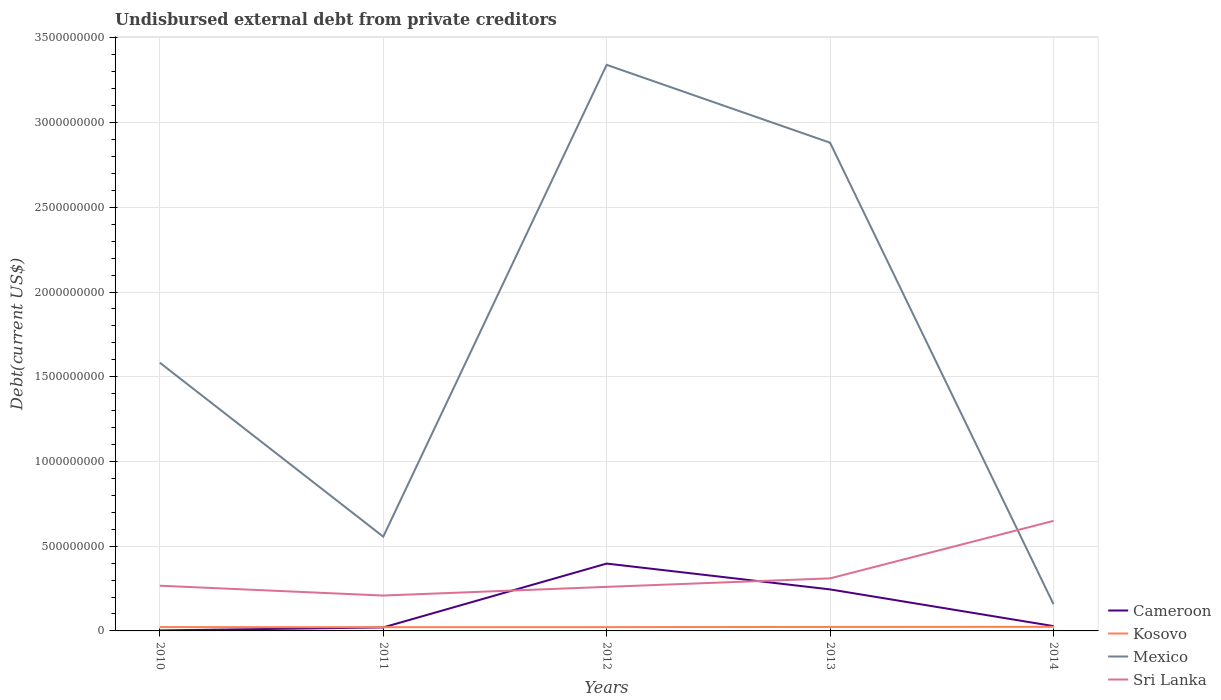Is the number of lines equal to the number of legend labels?
Ensure brevity in your answer.  Yes. Across all years, what is the maximum total debt in Sri Lanka?
Ensure brevity in your answer.  2.09e+08. In which year was the total debt in Kosovo maximum?
Your answer should be compact. 2011. What is the total total debt in Sri Lanka in the graph?
Ensure brevity in your answer.  -5.13e+07. What is the difference between the highest and the second highest total debt in Sri Lanka?
Your answer should be compact. 4.41e+08. How many lines are there?
Your answer should be very brief. 4. How many years are there in the graph?
Offer a very short reply. 5. What is the difference between two consecutive major ticks on the Y-axis?
Give a very brief answer. 5.00e+08. Are the values on the major ticks of Y-axis written in scientific E-notation?
Keep it short and to the point. No. Does the graph contain grids?
Your response must be concise. Yes. Where does the legend appear in the graph?
Provide a short and direct response. Bottom right. How are the legend labels stacked?
Give a very brief answer. Vertical. What is the title of the graph?
Provide a succinct answer. Undisbursed external debt from private creditors. What is the label or title of the X-axis?
Give a very brief answer. Years. What is the label or title of the Y-axis?
Offer a very short reply. Debt(current US$). What is the Debt(current US$) of Cameroon in 2010?
Make the answer very short. 2.98e+06. What is the Debt(current US$) of Kosovo in 2010?
Your answer should be compact. 2.27e+07. What is the Debt(current US$) of Mexico in 2010?
Your answer should be compact. 1.58e+09. What is the Debt(current US$) of Sri Lanka in 2010?
Offer a terse response. 2.67e+08. What is the Debt(current US$) of Cameroon in 2011?
Ensure brevity in your answer.  2.07e+07. What is the Debt(current US$) of Kosovo in 2011?
Your answer should be very brief. 2.20e+07. What is the Debt(current US$) in Mexico in 2011?
Your answer should be very brief. 5.56e+08. What is the Debt(current US$) of Sri Lanka in 2011?
Provide a short and direct response. 2.09e+08. What is the Debt(current US$) of Cameroon in 2012?
Provide a short and direct response. 3.98e+08. What is the Debt(current US$) in Kosovo in 2012?
Provide a short and direct response. 2.24e+07. What is the Debt(current US$) in Mexico in 2012?
Keep it short and to the point. 3.34e+09. What is the Debt(current US$) in Sri Lanka in 2012?
Your response must be concise. 2.60e+08. What is the Debt(current US$) of Cameroon in 2013?
Your response must be concise. 2.45e+08. What is the Debt(current US$) in Kosovo in 2013?
Offer a very short reply. 2.34e+07. What is the Debt(current US$) in Mexico in 2013?
Give a very brief answer. 2.88e+09. What is the Debt(current US$) in Sri Lanka in 2013?
Provide a succinct answer. 3.10e+08. What is the Debt(current US$) of Cameroon in 2014?
Your answer should be very brief. 2.85e+07. What is the Debt(current US$) of Kosovo in 2014?
Ensure brevity in your answer.  2.42e+07. What is the Debt(current US$) of Mexico in 2014?
Your answer should be compact. 1.58e+08. What is the Debt(current US$) of Sri Lanka in 2014?
Provide a succinct answer. 6.49e+08. Across all years, what is the maximum Debt(current US$) of Cameroon?
Make the answer very short. 3.98e+08. Across all years, what is the maximum Debt(current US$) in Kosovo?
Keep it short and to the point. 2.42e+07. Across all years, what is the maximum Debt(current US$) of Mexico?
Provide a short and direct response. 3.34e+09. Across all years, what is the maximum Debt(current US$) in Sri Lanka?
Offer a terse response. 6.49e+08. Across all years, what is the minimum Debt(current US$) in Cameroon?
Offer a very short reply. 2.98e+06. Across all years, what is the minimum Debt(current US$) in Kosovo?
Your answer should be very brief. 2.20e+07. Across all years, what is the minimum Debt(current US$) in Mexico?
Ensure brevity in your answer.  1.58e+08. Across all years, what is the minimum Debt(current US$) of Sri Lanka?
Provide a succinct answer. 2.09e+08. What is the total Debt(current US$) of Cameroon in the graph?
Provide a succinct answer. 6.95e+08. What is the total Debt(current US$) of Kosovo in the graph?
Offer a terse response. 1.15e+08. What is the total Debt(current US$) of Mexico in the graph?
Make the answer very short. 8.52e+09. What is the total Debt(current US$) in Sri Lanka in the graph?
Make the answer very short. 1.70e+09. What is the difference between the Debt(current US$) in Cameroon in 2010 and that in 2011?
Offer a terse response. -1.77e+07. What is the difference between the Debt(current US$) of Kosovo in 2010 and that in 2011?
Offer a terse response. 7.19e+05. What is the difference between the Debt(current US$) in Mexico in 2010 and that in 2011?
Your answer should be very brief. 1.03e+09. What is the difference between the Debt(current US$) of Sri Lanka in 2010 and that in 2011?
Keep it short and to the point. 5.81e+07. What is the difference between the Debt(current US$) of Cameroon in 2010 and that in 2012?
Offer a very short reply. -3.95e+08. What is the difference between the Debt(current US$) in Kosovo in 2010 and that in 2012?
Your answer should be very brief. 2.85e+05. What is the difference between the Debt(current US$) of Mexico in 2010 and that in 2012?
Provide a short and direct response. -1.76e+09. What is the difference between the Debt(current US$) in Sri Lanka in 2010 and that in 2012?
Your answer should be very brief. 6.78e+06. What is the difference between the Debt(current US$) in Cameroon in 2010 and that in 2013?
Your response must be concise. -2.42e+08. What is the difference between the Debt(current US$) in Kosovo in 2010 and that in 2013?
Your answer should be compact. -7.30e+05. What is the difference between the Debt(current US$) of Mexico in 2010 and that in 2013?
Provide a succinct answer. -1.30e+09. What is the difference between the Debt(current US$) in Sri Lanka in 2010 and that in 2013?
Provide a short and direct response. -4.33e+07. What is the difference between the Debt(current US$) of Cameroon in 2010 and that in 2014?
Provide a short and direct response. -2.55e+07. What is the difference between the Debt(current US$) in Kosovo in 2010 and that in 2014?
Provide a succinct answer. -1.48e+06. What is the difference between the Debt(current US$) of Mexico in 2010 and that in 2014?
Make the answer very short. 1.42e+09. What is the difference between the Debt(current US$) of Sri Lanka in 2010 and that in 2014?
Ensure brevity in your answer.  -3.83e+08. What is the difference between the Debt(current US$) of Cameroon in 2011 and that in 2012?
Provide a succinct answer. -3.77e+08. What is the difference between the Debt(current US$) of Kosovo in 2011 and that in 2012?
Keep it short and to the point. -4.34e+05. What is the difference between the Debt(current US$) in Mexico in 2011 and that in 2012?
Provide a succinct answer. -2.78e+09. What is the difference between the Debt(current US$) of Sri Lanka in 2011 and that in 2012?
Your answer should be very brief. -5.13e+07. What is the difference between the Debt(current US$) in Cameroon in 2011 and that in 2013?
Give a very brief answer. -2.24e+08. What is the difference between the Debt(current US$) in Kosovo in 2011 and that in 2013?
Make the answer very short. -1.45e+06. What is the difference between the Debt(current US$) in Mexico in 2011 and that in 2013?
Provide a short and direct response. -2.33e+09. What is the difference between the Debt(current US$) in Sri Lanka in 2011 and that in 2013?
Your answer should be very brief. -1.01e+08. What is the difference between the Debt(current US$) of Cameroon in 2011 and that in 2014?
Make the answer very short. -7.80e+06. What is the difference between the Debt(current US$) in Kosovo in 2011 and that in 2014?
Your response must be concise. -2.20e+06. What is the difference between the Debt(current US$) of Mexico in 2011 and that in 2014?
Give a very brief answer. 3.98e+08. What is the difference between the Debt(current US$) of Sri Lanka in 2011 and that in 2014?
Your response must be concise. -4.41e+08. What is the difference between the Debt(current US$) of Cameroon in 2012 and that in 2013?
Your answer should be compact. 1.52e+08. What is the difference between the Debt(current US$) in Kosovo in 2012 and that in 2013?
Give a very brief answer. -1.02e+06. What is the difference between the Debt(current US$) in Mexico in 2012 and that in 2013?
Keep it short and to the point. 4.59e+08. What is the difference between the Debt(current US$) in Sri Lanka in 2012 and that in 2013?
Your answer should be compact. -5.01e+07. What is the difference between the Debt(current US$) of Cameroon in 2012 and that in 2014?
Your response must be concise. 3.69e+08. What is the difference between the Debt(current US$) in Kosovo in 2012 and that in 2014?
Offer a very short reply. -1.77e+06. What is the difference between the Debt(current US$) in Mexico in 2012 and that in 2014?
Your response must be concise. 3.18e+09. What is the difference between the Debt(current US$) in Sri Lanka in 2012 and that in 2014?
Make the answer very short. -3.89e+08. What is the difference between the Debt(current US$) in Cameroon in 2013 and that in 2014?
Offer a terse response. 2.17e+08. What is the difference between the Debt(current US$) of Kosovo in 2013 and that in 2014?
Your answer should be very brief. -7.54e+05. What is the difference between the Debt(current US$) in Mexico in 2013 and that in 2014?
Your answer should be compact. 2.72e+09. What is the difference between the Debt(current US$) of Sri Lanka in 2013 and that in 2014?
Offer a terse response. -3.39e+08. What is the difference between the Debt(current US$) of Cameroon in 2010 and the Debt(current US$) of Kosovo in 2011?
Offer a terse response. -1.90e+07. What is the difference between the Debt(current US$) of Cameroon in 2010 and the Debt(current US$) of Mexico in 2011?
Offer a terse response. -5.53e+08. What is the difference between the Debt(current US$) in Cameroon in 2010 and the Debt(current US$) in Sri Lanka in 2011?
Your answer should be compact. -2.06e+08. What is the difference between the Debt(current US$) of Kosovo in 2010 and the Debt(current US$) of Mexico in 2011?
Ensure brevity in your answer.  -5.34e+08. What is the difference between the Debt(current US$) in Kosovo in 2010 and the Debt(current US$) in Sri Lanka in 2011?
Provide a succinct answer. -1.86e+08. What is the difference between the Debt(current US$) in Mexico in 2010 and the Debt(current US$) in Sri Lanka in 2011?
Keep it short and to the point. 1.37e+09. What is the difference between the Debt(current US$) of Cameroon in 2010 and the Debt(current US$) of Kosovo in 2012?
Your response must be concise. -1.94e+07. What is the difference between the Debt(current US$) of Cameroon in 2010 and the Debt(current US$) of Mexico in 2012?
Your response must be concise. -3.34e+09. What is the difference between the Debt(current US$) in Cameroon in 2010 and the Debt(current US$) in Sri Lanka in 2012?
Provide a succinct answer. -2.57e+08. What is the difference between the Debt(current US$) in Kosovo in 2010 and the Debt(current US$) in Mexico in 2012?
Provide a succinct answer. -3.32e+09. What is the difference between the Debt(current US$) of Kosovo in 2010 and the Debt(current US$) of Sri Lanka in 2012?
Make the answer very short. -2.37e+08. What is the difference between the Debt(current US$) of Mexico in 2010 and the Debt(current US$) of Sri Lanka in 2012?
Give a very brief answer. 1.32e+09. What is the difference between the Debt(current US$) of Cameroon in 2010 and the Debt(current US$) of Kosovo in 2013?
Give a very brief answer. -2.05e+07. What is the difference between the Debt(current US$) in Cameroon in 2010 and the Debt(current US$) in Mexico in 2013?
Keep it short and to the point. -2.88e+09. What is the difference between the Debt(current US$) of Cameroon in 2010 and the Debt(current US$) of Sri Lanka in 2013?
Give a very brief answer. -3.07e+08. What is the difference between the Debt(current US$) in Kosovo in 2010 and the Debt(current US$) in Mexico in 2013?
Your answer should be very brief. -2.86e+09. What is the difference between the Debt(current US$) of Kosovo in 2010 and the Debt(current US$) of Sri Lanka in 2013?
Provide a succinct answer. -2.87e+08. What is the difference between the Debt(current US$) in Mexico in 2010 and the Debt(current US$) in Sri Lanka in 2013?
Make the answer very short. 1.27e+09. What is the difference between the Debt(current US$) in Cameroon in 2010 and the Debt(current US$) in Kosovo in 2014?
Provide a succinct answer. -2.12e+07. What is the difference between the Debt(current US$) in Cameroon in 2010 and the Debt(current US$) in Mexico in 2014?
Provide a short and direct response. -1.55e+08. What is the difference between the Debt(current US$) in Cameroon in 2010 and the Debt(current US$) in Sri Lanka in 2014?
Offer a terse response. -6.46e+08. What is the difference between the Debt(current US$) in Kosovo in 2010 and the Debt(current US$) in Mexico in 2014?
Give a very brief answer. -1.35e+08. What is the difference between the Debt(current US$) of Kosovo in 2010 and the Debt(current US$) of Sri Lanka in 2014?
Give a very brief answer. -6.27e+08. What is the difference between the Debt(current US$) in Mexico in 2010 and the Debt(current US$) in Sri Lanka in 2014?
Provide a short and direct response. 9.34e+08. What is the difference between the Debt(current US$) in Cameroon in 2011 and the Debt(current US$) in Kosovo in 2012?
Offer a terse response. -1.76e+06. What is the difference between the Debt(current US$) of Cameroon in 2011 and the Debt(current US$) of Mexico in 2012?
Provide a succinct answer. -3.32e+09. What is the difference between the Debt(current US$) in Cameroon in 2011 and the Debt(current US$) in Sri Lanka in 2012?
Your answer should be very brief. -2.39e+08. What is the difference between the Debt(current US$) of Kosovo in 2011 and the Debt(current US$) of Mexico in 2012?
Your response must be concise. -3.32e+09. What is the difference between the Debt(current US$) of Kosovo in 2011 and the Debt(current US$) of Sri Lanka in 2012?
Offer a very short reply. -2.38e+08. What is the difference between the Debt(current US$) of Mexico in 2011 and the Debt(current US$) of Sri Lanka in 2012?
Keep it short and to the point. 2.96e+08. What is the difference between the Debt(current US$) in Cameroon in 2011 and the Debt(current US$) in Kosovo in 2013?
Your answer should be very brief. -2.78e+06. What is the difference between the Debt(current US$) of Cameroon in 2011 and the Debt(current US$) of Mexico in 2013?
Ensure brevity in your answer.  -2.86e+09. What is the difference between the Debt(current US$) of Cameroon in 2011 and the Debt(current US$) of Sri Lanka in 2013?
Your answer should be compact. -2.89e+08. What is the difference between the Debt(current US$) of Kosovo in 2011 and the Debt(current US$) of Mexico in 2013?
Your response must be concise. -2.86e+09. What is the difference between the Debt(current US$) of Kosovo in 2011 and the Debt(current US$) of Sri Lanka in 2013?
Offer a terse response. -2.88e+08. What is the difference between the Debt(current US$) in Mexico in 2011 and the Debt(current US$) in Sri Lanka in 2013?
Offer a terse response. 2.46e+08. What is the difference between the Debt(current US$) of Cameroon in 2011 and the Debt(current US$) of Kosovo in 2014?
Ensure brevity in your answer.  -3.53e+06. What is the difference between the Debt(current US$) of Cameroon in 2011 and the Debt(current US$) of Mexico in 2014?
Provide a short and direct response. -1.37e+08. What is the difference between the Debt(current US$) in Cameroon in 2011 and the Debt(current US$) in Sri Lanka in 2014?
Your answer should be compact. -6.29e+08. What is the difference between the Debt(current US$) of Kosovo in 2011 and the Debt(current US$) of Mexico in 2014?
Make the answer very short. -1.36e+08. What is the difference between the Debt(current US$) of Kosovo in 2011 and the Debt(current US$) of Sri Lanka in 2014?
Give a very brief answer. -6.27e+08. What is the difference between the Debt(current US$) in Mexico in 2011 and the Debt(current US$) in Sri Lanka in 2014?
Your answer should be very brief. -9.30e+07. What is the difference between the Debt(current US$) in Cameroon in 2012 and the Debt(current US$) in Kosovo in 2013?
Provide a short and direct response. 3.74e+08. What is the difference between the Debt(current US$) in Cameroon in 2012 and the Debt(current US$) in Mexico in 2013?
Provide a succinct answer. -2.48e+09. What is the difference between the Debt(current US$) of Cameroon in 2012 and the Debt(current US$) of Sri Lanka in 2013?
Keep it short and to the point. 8.74e+07. What is the difference between the Debt(current US$) of Kosovo in 2012 and the Debt(current US$) of Mexico in 2013?
Provide a short and direct response. -2.86e+09. What is the difference between the Debt(current US$) of Kosovo in 2012 and the Debt(current US$) of Sri Lanka in 2013?
Provide a short and direct response. -2.88e+08. What is the difference between the Debt(current US$) of Mexico in 2012 and the Debt(current US$) of Sri Lanka in 2013?
Provide a succinct answer. 3.03e+09. What is the difference between the Debt(current US$) of Cameroon in 2012 and the Debt(current US$) of Kosovo in 2014?
Provide a succinct answer. 3.73e+08. What is the difference between the Debt(current US$) in Cameroon in 2012 and the Debt(current US$) in Mexico in 2014?
Your answer should be very brief. 2.39e+08. What is the difference between the Debt(current US$) of Cameroon in 2012 and the Debt(current US$) of Sri Lanka in 2014?
Give a very brief answer. -2.52e+08. What is the difference between the Debt(current US$) of Kosovo in 2012 and the Debt(current US$) of Mexico in 2014?
Your answer should be compact. -1.36e+08. What is the difference between the Debt(current US$) in Kosovo in 2012 and the Debt(current US$) in Sri Lanka in 2014?
Your answer should be very brief. -6.27e+08. What is the difference between the Debt(current US$) in Mexico in 2012 and the Debt(current US$) in Sri Lanka in 2014?
Provide a succinct answer. 2.69e+09. What is the difference between the Debt(current US$) in Cameroon in 2013 and the Debt(current US$) in Kosovo in 2014?
Offer a terse response. 2.21e+08. What is the difference between the Debt(current US$) in Cameroon in 2013 and the Debt(current US$) in Mexico in 2014?
Offer a very short reply. 8.69e+07. What is the difference between the Debt(current US$) in Cameroon in 2013 and the Debt(current US$) in Sri Lanka in 2014?
Keep it short and to the point. -4.04e+08. What is the difference between the Debt(current US$) in Kosovo in 2013 and the Debt(current US$) in Mexico in 2014?
Provide a succinct answer. -1.35e+08. What is the difference between the Debt(current US$) in Kosovo in 2013 and the Debt(current US$) in Sri Lanka in 2014?
Ensure brevity in your answer.  -6.26e+08. What is the difference between the Debt(current US$) in Mexico in 2013 and the Debt(current US$) in Sri Lanka in 2014?
Offer a terse response. 2.23e+09. What is the average Debt(current US$) in Cameroon per year?
Your answer should be very brief. 1.39e+08. What is the average Debt(current US$) of Kosovo per year?
Keep it short and to the point. 2.30e+07. What is the average Debt(current US$) of Mexico per year?
Offer a very short reply. 1.70e+09. What is the average Debt(current US$) in Sri Lanka per year?
Keep it short and to the point. 3.39e+08. In the year 2010, what is the difference between the Debt(current US$) of Cameroon and Debt(current US$) of Kosovo?
Offer a terse response. -1.97e+07. In the year 2010, what is the difference between the Debt(current US$) in Cameroon and Debt(current US$) in Mexico?
Make the answer very short. -1.58e+09. In the year 2010, what is the difference between the Debt(current US$) in Cameroon and Debt(current US$) in Sri Lanka?
Provide a succinct answer. -2.64e+08. In the year 2010, what is the difference between the Debt(current US$) in Kosovo and Debt(current US$) in Mexico?
Your response must be concise. -1.56e+09. In the year 2010, what is the difference between the Debt(current US$) in Kosovo and Debt(current US$) in Sri Lanka?
Make the answer very short. -2.44e+08. In the year 2010, what is the difference between the Debt(current US$) of Mexico and Debt(current US$) of Sri Lanka?
Make the answer very short. 1.32e+09. In the year 2011, what is the difference between the Debt(current US$) in Cameroon and Debt(current US$) in Kosovo?
Offer a very short reply. -1.33e+06. In the year 2011, what is the difference between the Debt(current US$) of Cameroon and Debt(current US$) of Mexico?
Your answer should be very brief. -5.36e+08. In the year 2011, what is the difference between the Debt(current US$) in Cameroon and Debt(current US$) in Sri Lanka?
Offer a very short reply. -1.88e+08. In the year 2011, what is the difference between the Debt(current US$) of Kosovo and Debt(current US$) of Mexico?
Your answer should be very brief. -5.34e+08. In the year 2011, what is the difference between the Debt(current US$) in Kosovo and Debt(current US$) in Sri Lanka?
Your answer should be compact. -1.87e+08. In the year 2011, what is the difference between the Debt(current US$) in Mexico and Debt(current US$) in Sri Lanka?
Provide a short and direct response. 3.48e+08. In the year 2012, what is the difference between the Debt(current US$) of Cameroon and Debt(current US$) of Kosovo?
Ensure brevity in your answer.  3.75e+08. In the year 2012, what is the difference between the Debt(current US$) in Cameroon and Debt(current US$) in Mexico?
Your answer should be compact. -2.94e+09. In the year 2012, what is the difference between the Debt(current US$) in Cameroon and Debt(current US$) in Sri Lanka?
Offer a very short reply. 1.37e+08. In the year 2012, what is the difference between the Debt(current US$) of Kosovo and Debt(current US$) of Mexico?
Ensure brevity in your answer.  -3.32e+09. In the year 2012, what is the difference between the Debt(current US$) in Kosovo and Debt(current US$) in Sri Lanka?
Keep it short and to the point. -2.38e+08. In the year 2012, what is the difference between the Debt(current US$) in Mexico and Debt(current US$) in Sri Lanka?
Make the answer very short. 3.08e+09. In the year 2013, what is the difference between the Debt(current US$) in Cameroon and Debt(current US$) in Kosovo?
Your answer should be very brief. 2.22e+08. In the year 2013, what is the difference between the Debt(current US$) of Cameroon and Debt(current US$) of Mexico?
Keep it short and to the point. -2.64e+09. In the year 2013, what is the difference between the Debt(current US$) of Cameroon and Debt(current US$) of Sri Lanka?
Your answer should be compact. -6.51e+07. In the year 2013, what is the difference between the Debt(current US$) in Kosovo and Debt(current US$) in Mexico?
Your answer should be very brief. -2.86e+09. In the year 2013, what is the difference between the Debt(current US$) in Kosovo and Debt(current US$) in Sri Lanka?
Offer a very short reply. -2.87e+08. In the year 2013, what is the difference between the Debt(current US$) in Mexico and Debt(current US$) in Sri Lanka?
Your answer should be very brief. 2.57e+09. In the year 2014, what is the difference between the Debt(current US$) of Cameroon and Debt(current US$) of Kosovo?
Provide a succinct answer. 4.27e+06. In the year 2014, what is the difference between the Debt(current US$) of Cameroon and Debt(current US$) of Mexico?
Offer a very short reply. -1.30e+08. In the year 2014, what is the difference between the Debt(current US$) of Cameroon and Debt(current US$) of Sri Lanka?
Make the answer very short. -6.21e+08. In the year 2014, what is the difference between the Debt(current US$) of Kosovo and Debt(current US$) of Mexico?
Your answer should be very brief. -1.34e+08. In the year 2014, what is the difference between the Debt(current US$) of Kosovo and Debt(current US$) of Sri Lanka?
Offer a terse response. -6.25e+08. In the year 2014, what is the difference between the Debt(current US$) in Mexico and Debt(current US$) in Sri Lanka?
Ensure brevity in your answer.  -4.91e+08. What is the ratio of the Debt(current US$) of Cameroon in 2010 to that in 2011?
Your answer should be very brief. 0.14. What is the ratio of the Debt(current US$) in Kosovo in 2010 to that in 2011?
Your response must be concise. 1.03. What is the ratio of the Debt(current US$) of Mexico in 2010 to that in 2011?
Provide a succinct answer. 2.85. What is the ratio of the Debt(current US$) in Sri Lanka in 2010 to that in 2011?
Your answer should be very brief. 1.28. What is the ratio of the Debt(current US$) of Cameroon in 2010 to that in 2012?
Give a very brief answer. 0.01. What is the ratio of the Debt(current US$) in Kosovo in 2010 to that in 2012?
Your answer should be very brief. 1.01. What is the ratio of the Debt(current US$) of Mexico in 2010 to that in 2012?
Provide a short and direct response. 0.47. What is the ratio of the Debt(current US$) in Sri Lanka in 2010 to that in 2012?
Offer a very short reply. 1.03. What is the ratio of the Debt(current US$) of Cameroon in 2010 to that in 2013?
Your answer should be very brief. 0.01. What is the ratio of the Debt(current US$) in Kosovo in 2010 to that in 2013?
Offer a terse response. 0.97. What is the ratio of the Debt(current US$) of Mexico in 2010 to that in 2013?
Offer a very short reply. 0.55. What is the ratio of the Debt(current US$) in Sri Lanka in 2010 to that in 2013?
Your response must be concise. 0.86. What is the ratio of the Debt(current US$) in Cameroon in 2010 to that in 2014?
Offer a very short reply. 0.1. What is the ratio of the Debt(current US$) of Kosovo in 2010 to that in 2014?
Your answer should be very brief. 0.94. What is the ratio of the Debt(current US$) in Mexico in 2010 to that in 2014?
Make the answer very short. 10.01. What is the ratio of the Debt(current US$) of Sri Lanka in 2010 to that in 2014?
Offer a terse response. 0.41. What is the ratio of the Debt(current US$) of Cameroon in 2011 to that in 2012?
Your answer should be compact. 0.05. What is the ratio of the Debt(current US$) in Kosovo in 2011 to that in 2012?
Give a very brief answer. 0.98. What is the ratio of the Debt(current US$) in Mexico in 2011 to that in 2012?
Make the answer very short. 0.17. What is the ratio of the Debt(current US$) in Sri Lanka in 2011 to that in 2012?
Provide a succinct answer. 0.8. What is the ratio of the Debt(current US$) of Cameroon in 2011 to that in 2013?
Provide a short and direct response. 0.08. What is the ratio of the Debt(current US$) of Kosovo in 2011 to that in 2013?
Keep it short and to the point. 0.94. What is the ratio of the Debt(current US$) in Mexico in 2011 to that in 2013?
Offer a very short reply. 0.19. What is the ratio of the Debt(current US$) of Sri Lanka in 2011 to that in 2013?
Your response must be concise. 0.67. What is the ratio of the Debt(current US$) of Cameroon in 2011 to that in 2014?
Provide a short and direct response. 0.73. What is the ratio of the Debt(current US$) in Kosovo in 2011 to that in 2014?
Give a very brief answer. 0.91. What is the ratio of the Debt(current US$) of Mexico in 2011 to that in 2014?
Make the answer very short. 3.52. What is the ratio of the Debt(current US$) of Sri Lanka in 2011 to that in 2014?
Provide a succinct answer. 0.32. What is the ratio of the Debt(current US$) of Cameroon in 2012 to that in 2013?
Your answer should be very brief. 1.62. What is the ratio of the Debt(current US$) in Kosovo in 2012 to that in 2013?
Provide a short and direct response. 0.96. What is the ratio of the Debt(current US$) of Mexico in 2012 to that in 2013?
Your answer should be very brief. 1.16. What is the ratio of the Debt(current US$) of Sri Lanka in 2012 to that in 2013?
Offer a very short reply. 0.84. What is the ratio of the Debt(current US$) of Cameroon in 2012 to that in 2014?
Your answer should be compact. 13.96. What is the ratio of the Debt(current US$) of Kosovo in 2012 to that in 2014?
Give a very brief answer. 0.93. What is the ratio of the Debt(current US$) in Mexico in 2012 to that in 2014?
Keep it short and to the point. 21.13. What is the ratio of the Debt(current US$) of Sri Lanka in 2012 to that in 2014?
Your response must be concise. 0.4. What is the ratio of the Debt(current US$) in Cameroon in 2013 to that in 2014?
Provide a succinct answer. 8.61. What is the ratio of the Debt(current US$) in Kosovo in 2013 to that in 2014?
Your answer should be compact. 0.97. What is the ratio of the Debt(current US$) in Mexico in 2013 to that in 2014?
Ensure brevity in your answer.  18.23. What is the ratio of the Debt(current US$) in Sri Lanka in 2013 to that in 2014?
Make the answer very short. 0.48. What is the difference between the highest and the second highest Debt(current US$) of Cameroon?
Your answer should be compact. 1.52e+08. What is the difference between the highest and the second highest Debt(current US$) of Kosovo?
Your response must be concise. 7.54e+05. What is the difference between the highest and the second highest Debt(current US$) of Mexico?
Provide a succinct answer. 4.59e+08. What is the difference between the highest and the second highest Debt(current US$) of Sri Lanka?
Provide a short and direct response. 3.39e+08. What is the difference between the highest and the lowest Debt(current US$) in Cameroon?
Keep it short and to the point. 3.95e+08. What is the difference between the highest and the lowest Debt(current US$) in Kosovo?
Give a very brief answer. 2.20e+06. What is the difference between the highest and the lowest Debt(current US$) in Mexico?
Keep it short and to the point. 3.18e+09. What is the difference between the highest and the lowest Debt(current US$) in Sri Lanka?
Make the answer very short. 4.41e+08. 